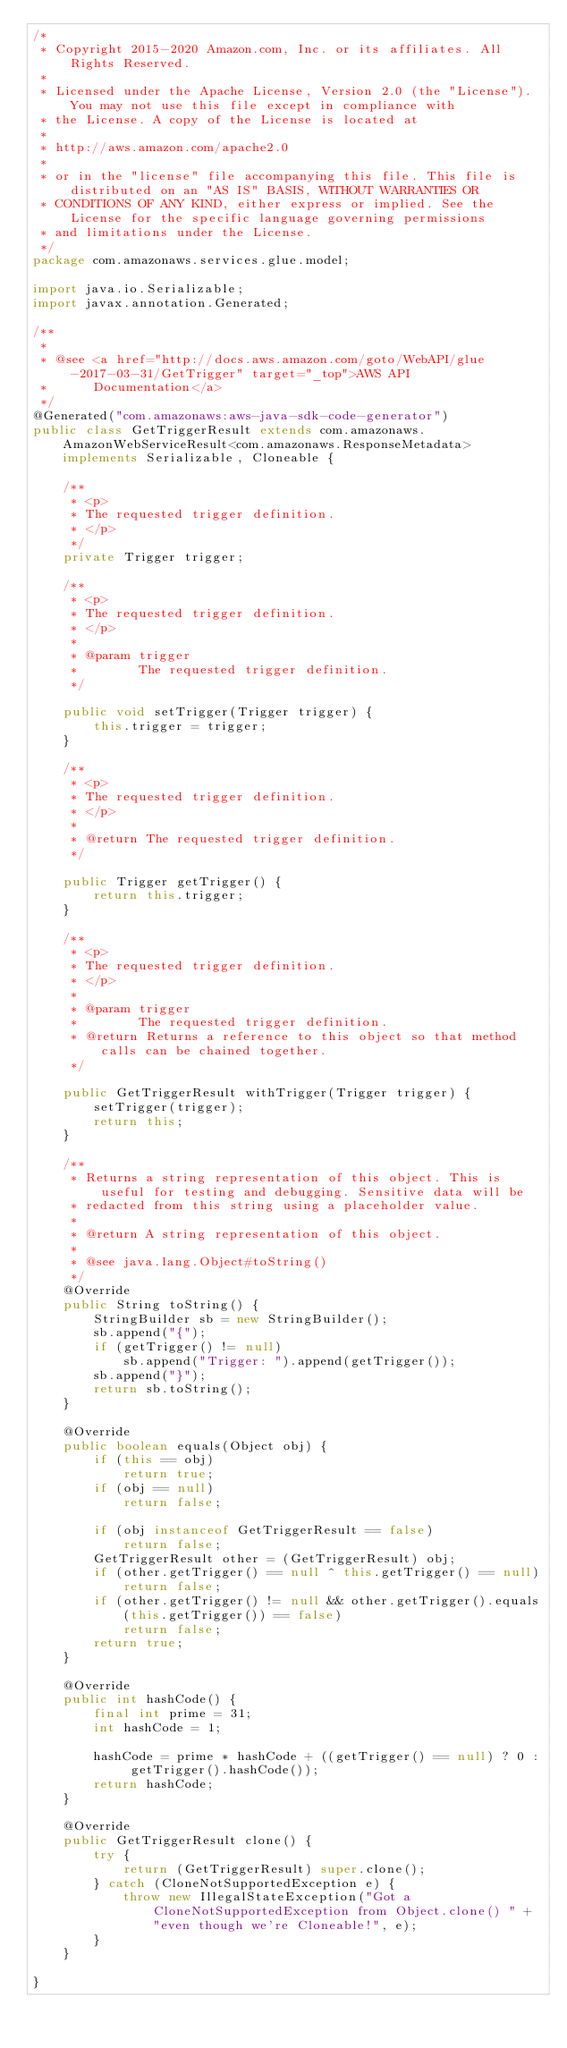Convert code to text. <code><loc_0><loc_0><loc_500><loc_500><_Java_>/*
 * Copyright 2015-2020 Amazon.com, Inc. or its affiliates. All Rights Reserved.
 * 
 * Licensed under the Apache License, Version 2.0 (the "License"). You may not use this file except in compliance with
 * the License. A copy of the License is located at
 * 
 * http://aws.amazon.com/apache2.0
 * 
 * or in the "license" file accompanying this file. This file is distributed on an "AS IS" BASIS, WITHOUT WARRANTIES OR
 * CONDITIONS OF ANY KIND, either express or implied. See the License for the specific language governing permissions
 * and limitations under the License.
 */
package com.amazonaws.services.glue.model;

import java.io.Serializable;
import javax.annotation.Generated;

/**
 * 
 * @see <a href="http://docs.aws.amazon.com/goto/WebAPI/glue-2017-03-31/GetTrigger" target="_top">AWS API
 *      Documentation</a>
 */
@Generated("com.amazonaws:aws-java-sdk-code-generator")
public class GetTriggerResult extends com.amazonaws.AmazonWebServiceResult<com.amazonaws.ResponseMetadata> implements Serializable, Cloneable {

    /**
     * <p>
     * The requested trigger definition.
     * </p>
     */
    private Trigger trigger;

    /**
     * <p>
     * The requested trigger definition.
     * </p>
     * 
     * @param trigger
     *        The requested trigger definition.
     */

    public void setTrigger(Trigger trigger) {
        this.trigger = trigger;
    }

    /**
     * <p>
     * The requested trigger definition.
     * </p>
     * 
     * @return The requested trigger definition.
     */

    public Trigger getTrigger() {
        return this.trigger;
    }

    /**
     * <p>
     * The requested trigger definition.
     * </p>
     * 
     * @param trigger
     *        The requested trigger definition.
     * @return Returns a reference to this object so that method calls can be chained together.
     */

    public GetTriggerResult withTrigger(Trigger trigger) {
        setTrigger(trigger);
        return this;
    }

    /**
     * Returns a string representation of this object. This is useful for testing and debugging. Sensitive data will be
     * redacted from this string using a placeholder value.
     *
     * @return A string representation of this object.
     *
     * @see java.lang.Object#toString()
     */
    @Override
    public String toString() {
        StringBuilder sb = new StringBuilder();
        sb.append("{");
        if (getTrigger() != null)
            sb.append("Trigger: ").append(getTrigger());
        sb.append("}");
        return sb.toString();
    }

    @Override
    public boolean equals(Object obj) {
        if (this == obj)
            return true;
        if (obj == null)
            return false;

        if (obj instanceof GetTriggerResult == false)
            return false;
        GetTriggerResult other = (GetTriggerResult) obj;
        if (other.getTrigger() == null ^ this.getTrigger() == null)
            return false;
        if (other.getTrigger() != null && other.getTrigger().equals(this.getTrigger()) == false)
            return false;
        return true;
    }

    @Override
    public int hashCode() {
        final int prime = 31;
        int hashCode = 1;

        hashCode = prime * hashCode + ((getTrigger() == null) ? 0 : getTrigger().hashCode());
        return hashCode;
    }

    @Override
    public GetTriggerResult clone() {
        try {
            return (GetTriggerResult) super.clone();
        } catch (CloneNotSupportedException e) {
            throw new IllegalStateException("Got a CloneNotSupportedException from Object.clone() " + "even though we're Cloneable!", e);
        }
    }

}
</code> 